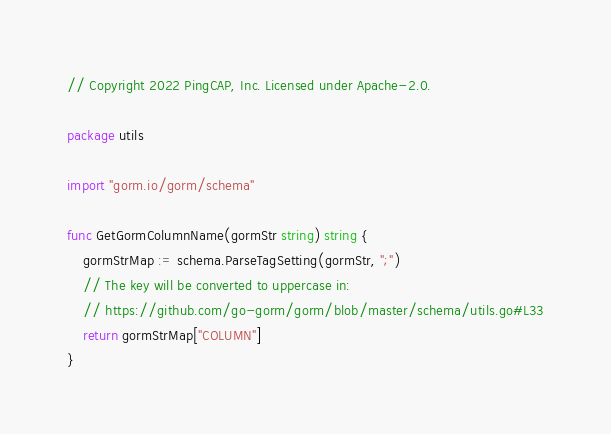<code> <loc_0><loc_0><loc_500><loc_500><_Go_>// Copyright 2022 PingCAP, Inc. Licensed under Apache-2.0.

package utils

import "gorm.io/gorm/schema"

func GetGormColumnName(gormStr string) string {
	gormStrMap := schema.ParseTagSetting(gormStr, ";")
	// The key will be converted to uppercase in:
	// https://github.com/go-gorm/gorm/blob/master/schema/utils.go#L33
	return gormStrMap["COLUMN"]
}
</code> 